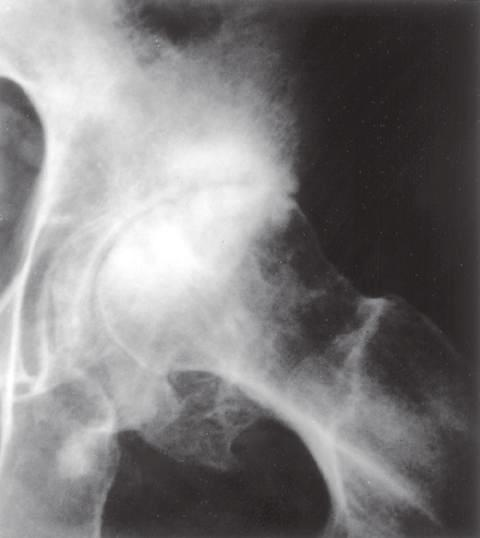what does subchondral sclerosis have?
Answer the question using a single word or phrase. Scattered oval radiolucent cysts and peripheral osteophyte lipping 